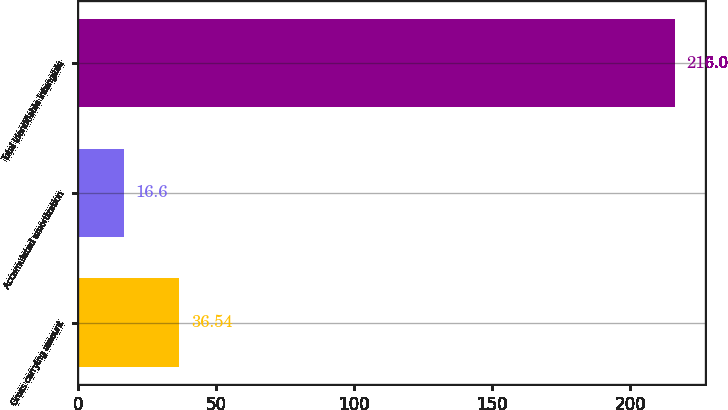Convert chart to OTSL. <chart><loc_0><loc_0><loc_500><loc_500><bar_chart><fcel>Gross carrying amount<fcel>Accumulated amortization<fcel>Total identifiable intangible<nl><fcel>36.54<fcel>16.6<fcel>216<nl></chart> 